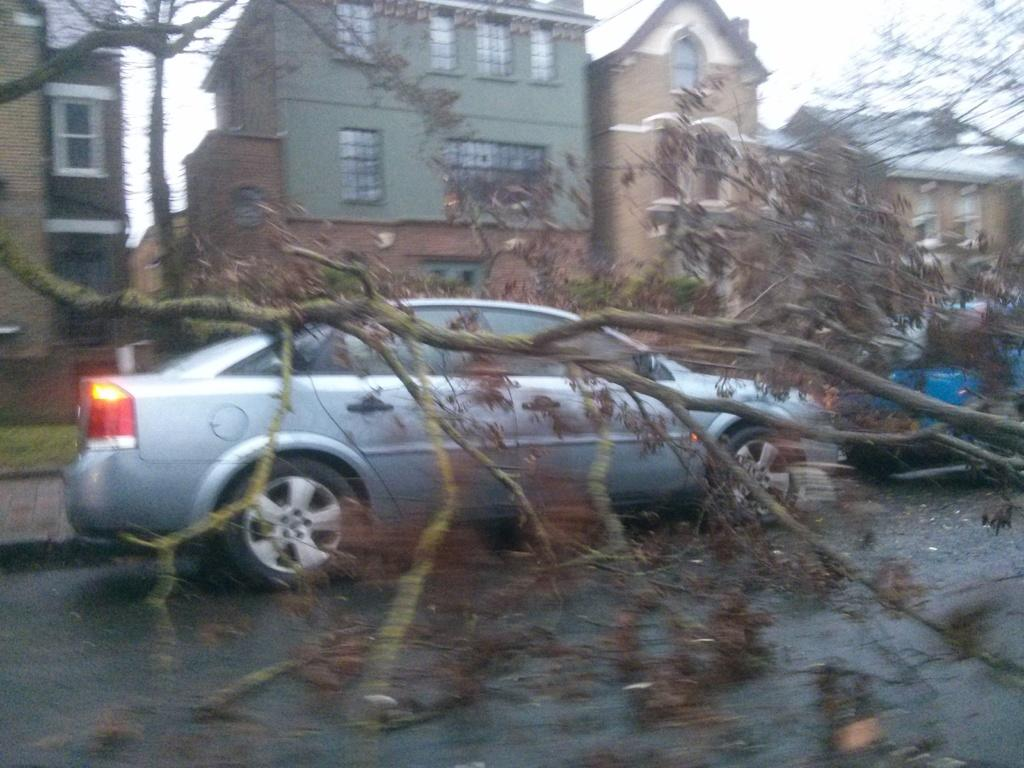What type of structures can be seen in the image? There are many buildings in the image. What else can be seen in the image besides buildings? There are many trees and a road in the image. How many cars are visible in the image? There are two cars in the image. What is visible in the background of the image? There is a sky visible in the image. What type of feast is being prepared in the image? There is no feast or any indication of food preparation in the image. What type of teeth can be seen in the image? There are no teeth visible in the image. 